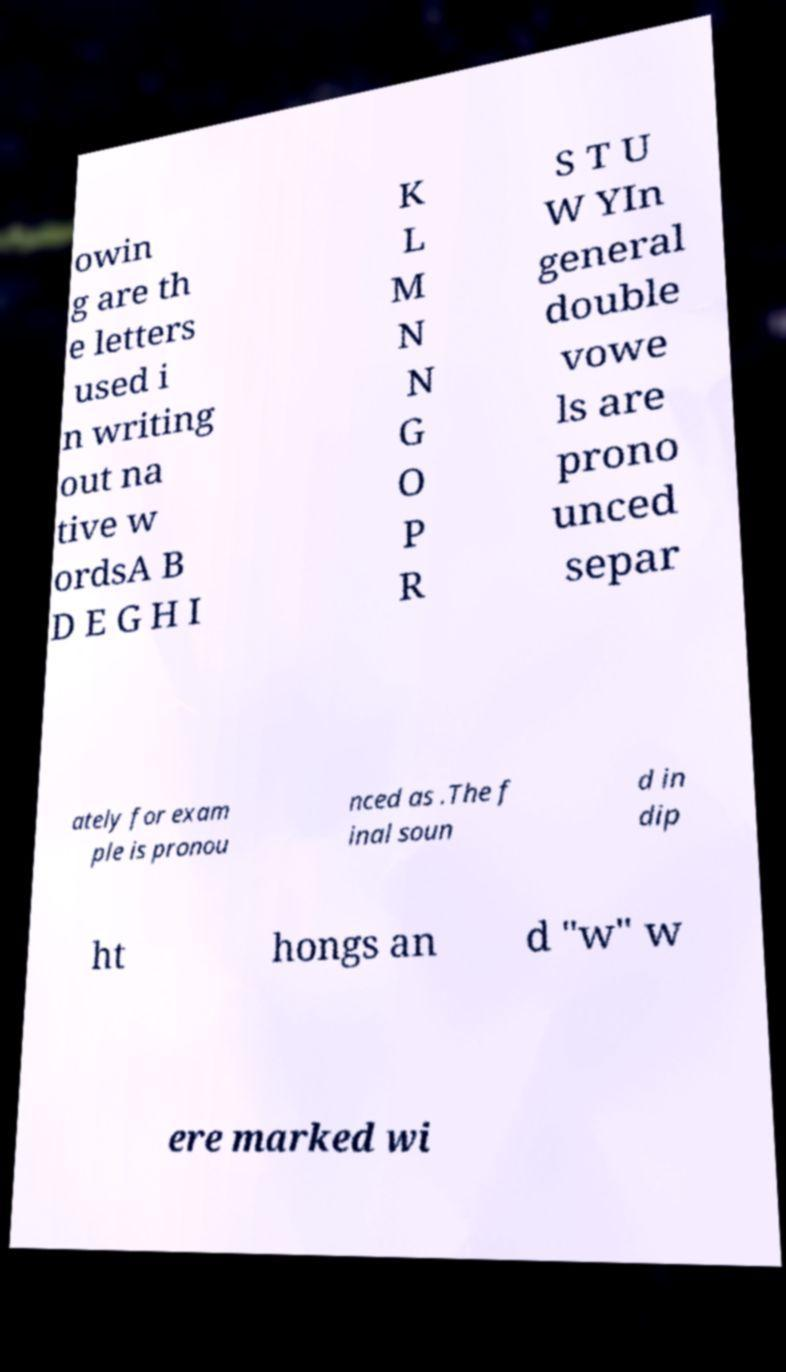Could you assist in decoding the text presented in this image and type it out clearly? owin g are th e letters used i n writing out na tive w ordsA B D E G H I K L M N N G O P R S T U W YIn general double vowe ls are prono unced separ ately for exam ple is pronou nced as .The f inal soun d in dip ht hongs an d "w" w ere marked wi 